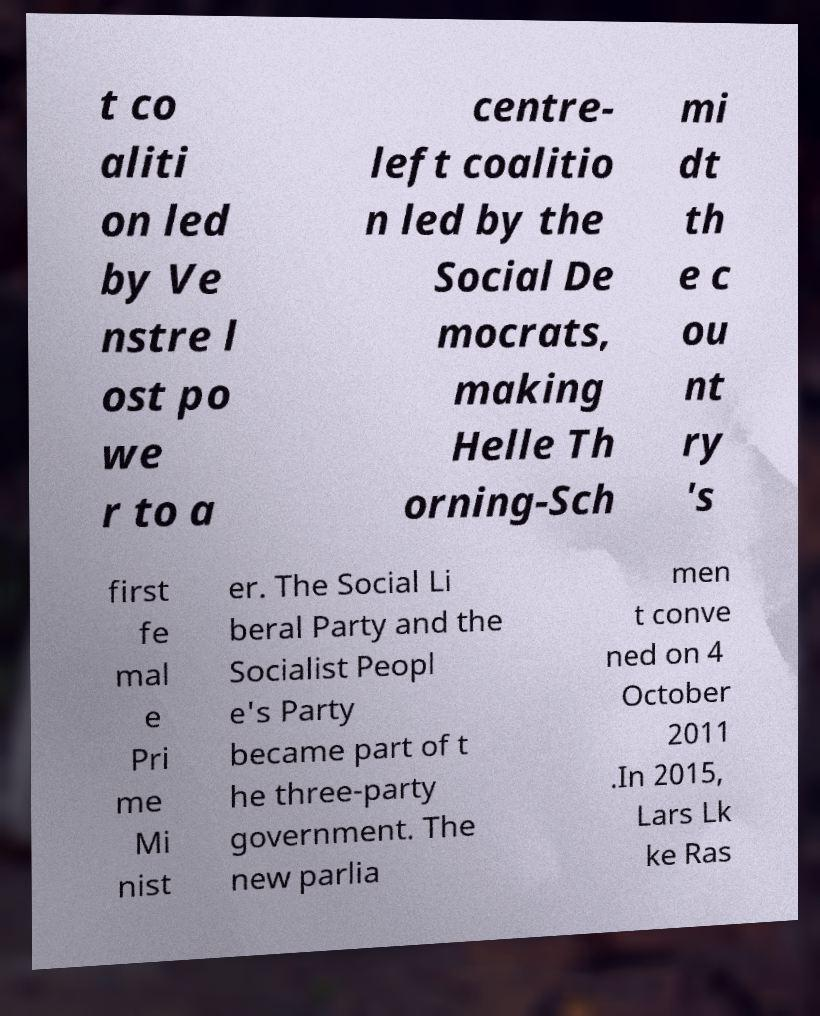Please identify and transcribe the text found in this image. t co aliti on led by Ve nstre l ost po we r to a centre- left coalitio n led by the Social De mocrats, making Helle Th orning-Sch mi dt th e c ou nt ry 's first fe mal e Pri me Mi nist er. The Social Li beral Party and the Socialist Peopl e's Party became part of t he three-party government. The new parlia men t conve ned on 4 October 2011 .In 2015, Lars Lk ke Ras 